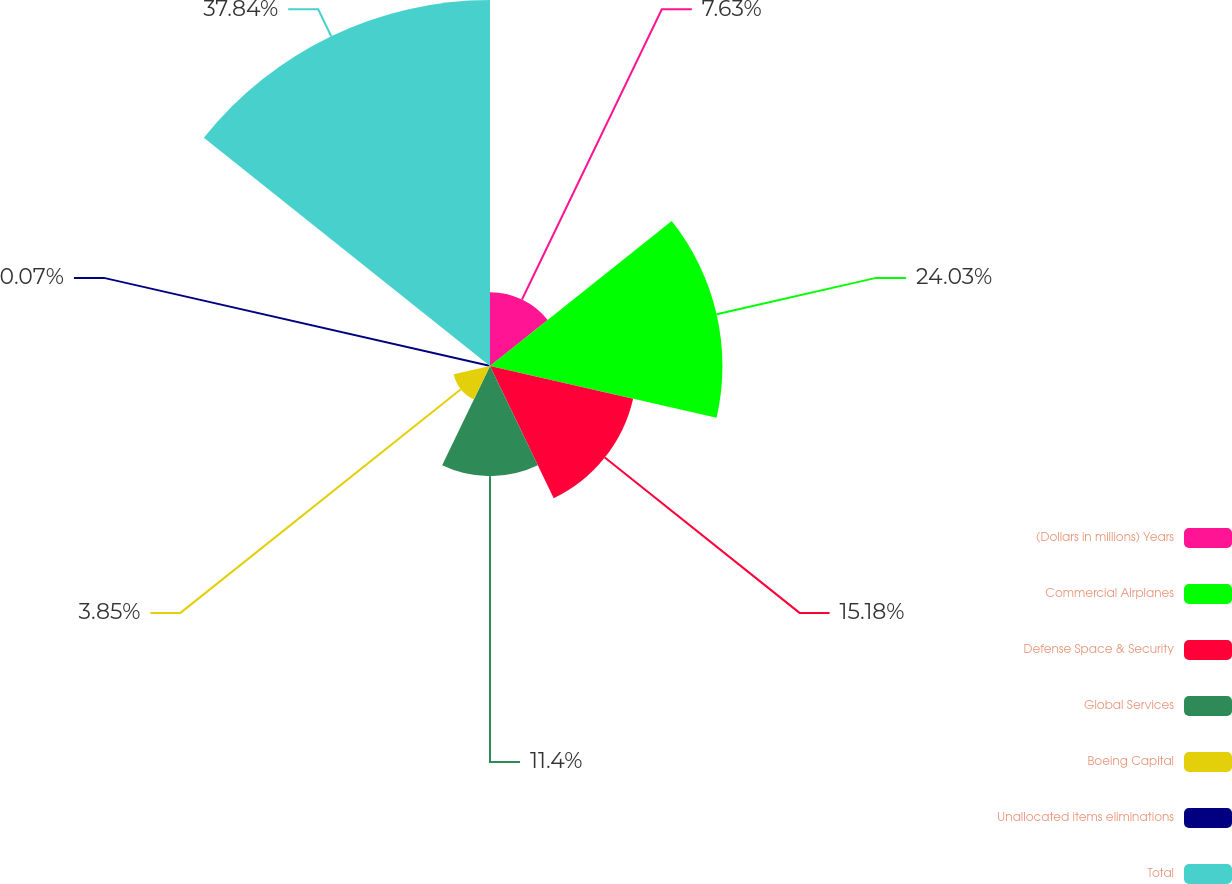<chart> <loc_0><loc_0><loc_500><loc_500><pie_chart><fcel>(Dollars in millions) Years<fcel>Commercial Airplanes<fcel>Defense Space & Security<fcel>Global Services<fcel>Boeing Capital<fcel>Unallocated items eliminations<fcel>Total<nl><fcel>7.63%<fcel>24.03%<fcel>15.18%<fcel>11.4%<fcel>3.85%<fcel>0.07%<fcel>37.84%<nl></chart> 